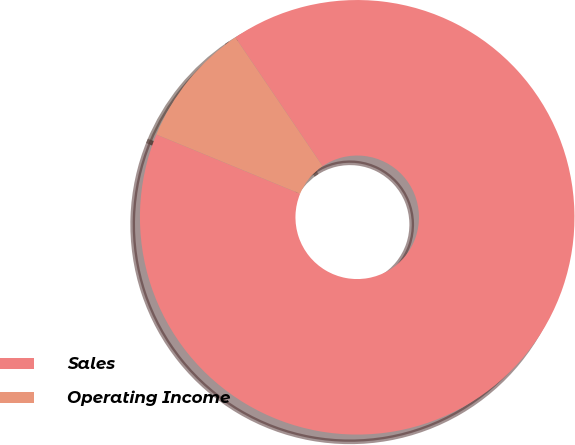Convert chart to OTSL. <chart><loc_0><loc_0><loc_500><loc_500><pie_chart><fcel>Sales<fcel>Operating Income<nl><fcel>90.7%<fcel>9.3%<nl></chart> 